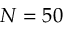Convert formula to latex. <formula><loc_0><loc_0><loc_500><loc_500>N = 5 0</formula> 